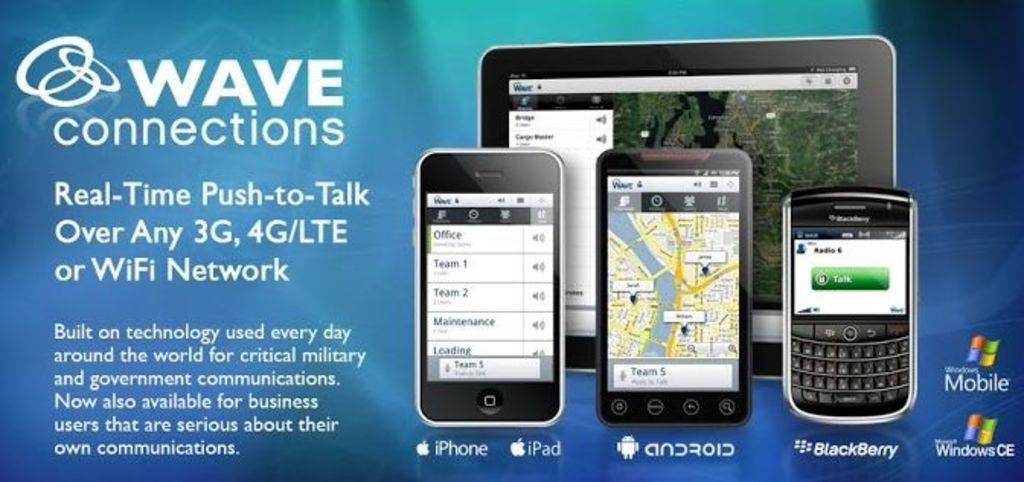<image>
Describe the image concisely. Picture of three cellphones and a ipad from wave connections 